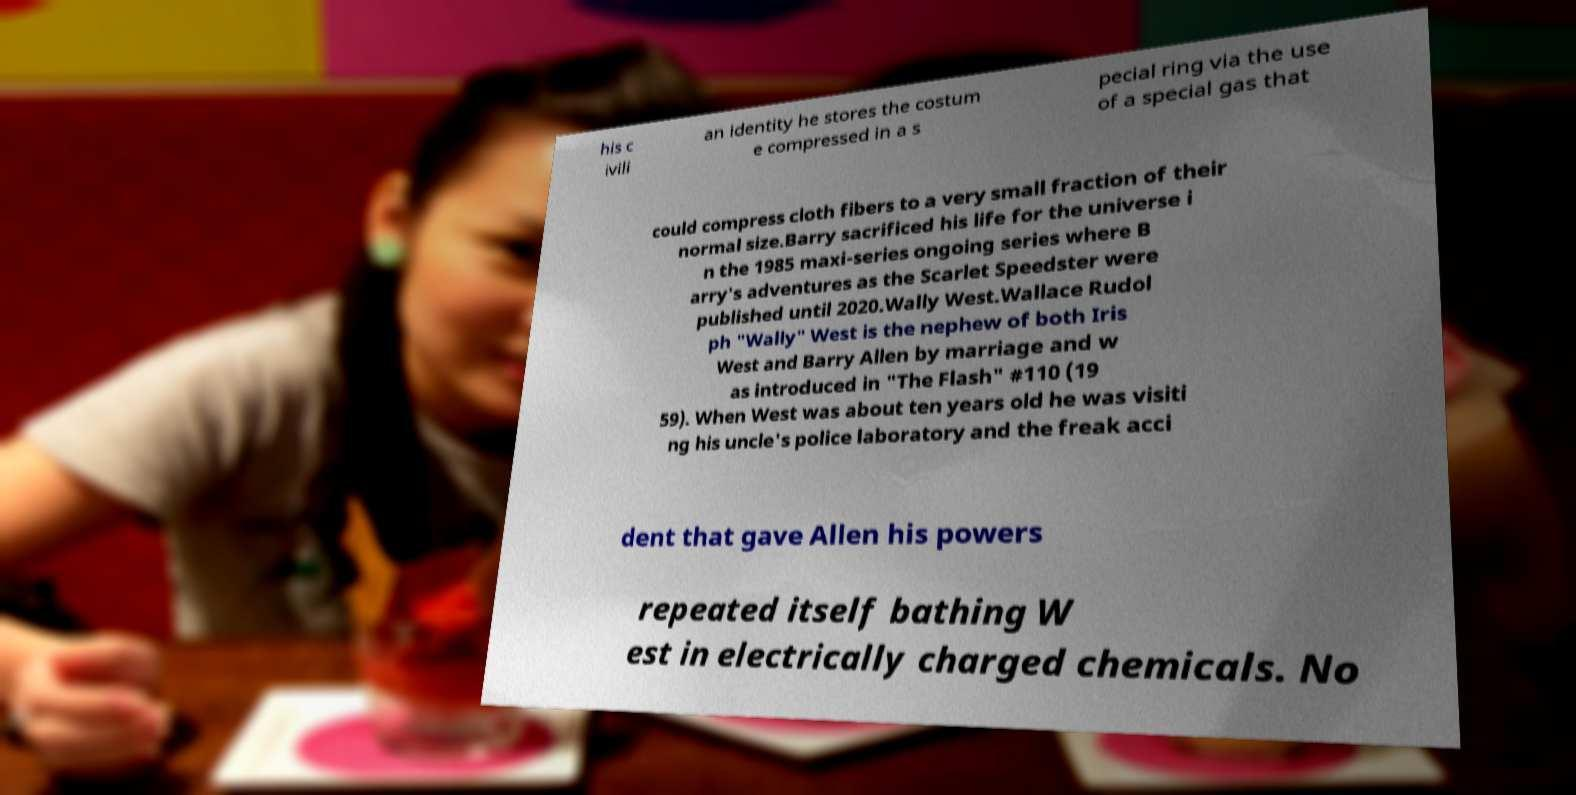Please identify and transcribe the text found in this image. his c ivili an identity he stores the costum e compressed in a s pecial ring via the use of a special gas that could compress cloth fibers to a very small fraction of their normal size.Barry sacrificed his life for the universe i n the 1985 maxi-series ongoing series where B arry's adventures as the Scarlet Speedster were published until 2020.Wally West.Wallace Rudol ph "Wally" West is the nephew of both Iris West and Barry Allen by marriage and w as introduced in "The Flash" #110 (19 59). When West was about ten years old he was visiti ng his uncle's police laboratory and the freak acci dent that gave Allen his powers repeated itself bathing W est in electrically charged chemicals. No 